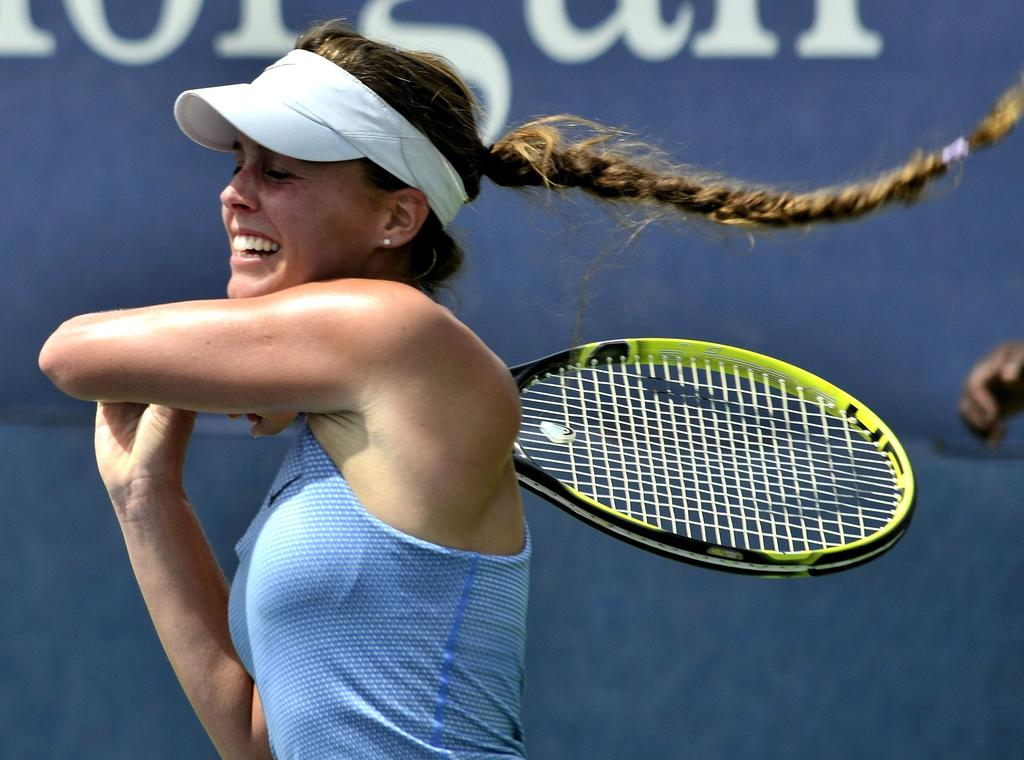Who is the main subject in the image? There is a woman in the image. What is the woman holding in the image? The woman is holding a bat. What is the woman's facial expression in the image? The woman is smiling. What can be seen on the wall behind the woman? There is some text written on the wall behind her. What can be seen on the back side of the woman? There is some text written on the back side of the woman. What is the farmer's thought process while walking the route in the image? There is no farmer or route present in the image; it features a woman holding a bat and smiling. 